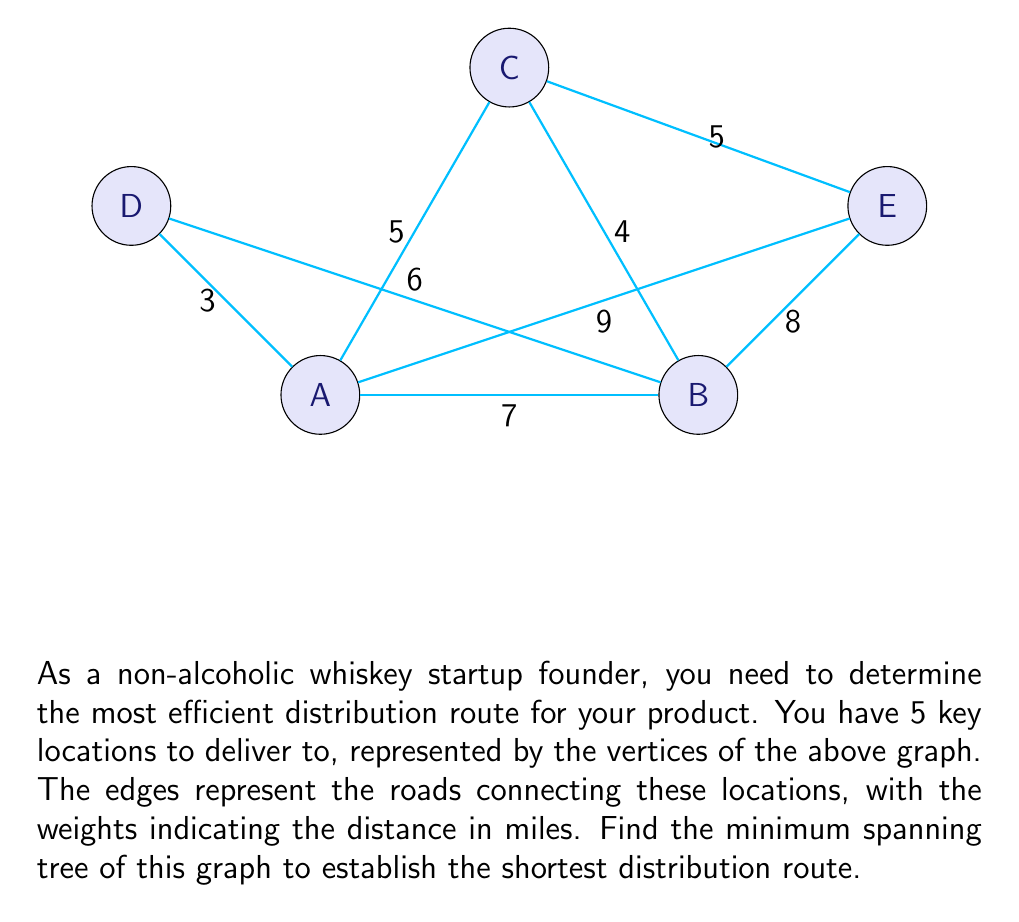Provide a solution to this math problem. To find the minimum spanning tree, we can use Kruskal's algorithm:

1) Sort all edges by weight in ascending order:
   AD (3), BC (4), AC (5), CE (5), BD (6), AB (7), BE (8), AE (9)

2) Start with an empty graph and add edges one by one, skipping those that would create a cycle:

   - Add AD (3)
   - Add BC (4)
   - Add AC (5)
   - Add CE (5)
   - Skip BD (6) as it would create a cycle
   - Skip AB (7) as it would create a cycle
   - Skip BE (8) as it would create a cycle
   - Skip AE (9) as it would create a cycle

3) The resulting minimum spanning tree consists of edges:
   AD (3), BC (4), AC (5), CE (5)

4) Calculate the total distance:
   $$3 + 4 + 5 + 5 = 17$$

Therefore, the minimum spanning tree has a total distance of 17 miles, connecting all locations with the shortest possible route.
Answer: 17 miles 